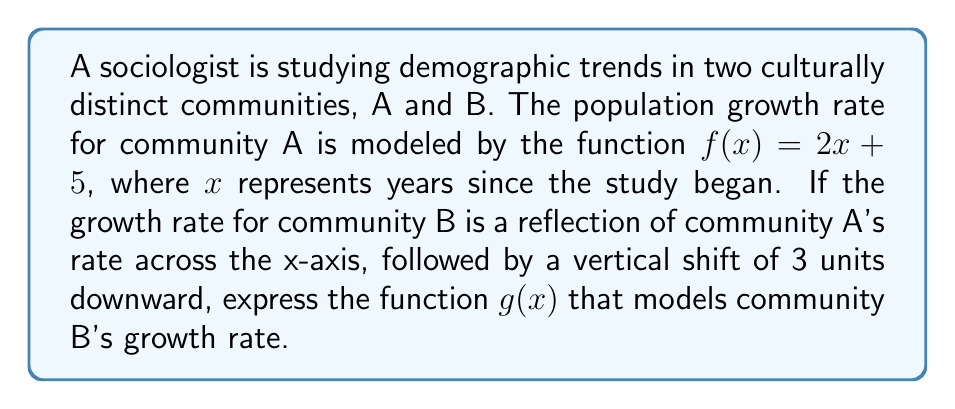What is the answer to this math problem? 1. Start with the original function for community A: $f(x) = 2x + 5$

2. To reflect across the x-axis, multiply the function by -1:
   $-f(x) = -(2x + 5) = -2x - 5$

3. For the vertical shift of 3 units downward, subtract 3 from the function:
   $g(x) = -2x - 5 - 3$

4. Simplify:
   $g(x) = -2x - 8$

This function $g(x)$ represents the growth rate of community B after applying the reflection and vertical shift transformations to community A's growth rate function.
Answer: $g(x) = -2x - 8$ 